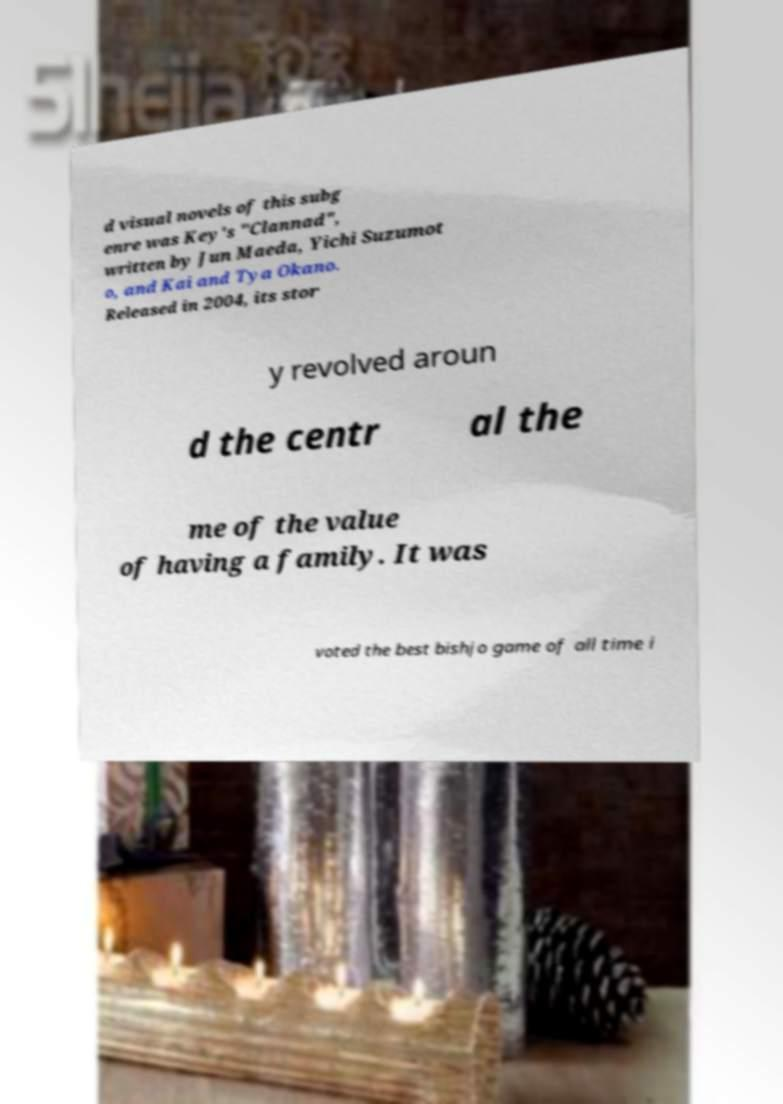What messages or text are displayed in this image? I need them in a readable, typed format. d visual novels of this subg enre was Key's "Clannad", written by Jun Maeda, Yichi Suzumot o, and Kai and Tya Okano. Released in 2004, its stor y revolved aroun d the centr al the me of the value of having a family. It was voted the best bishjo game of all time i 